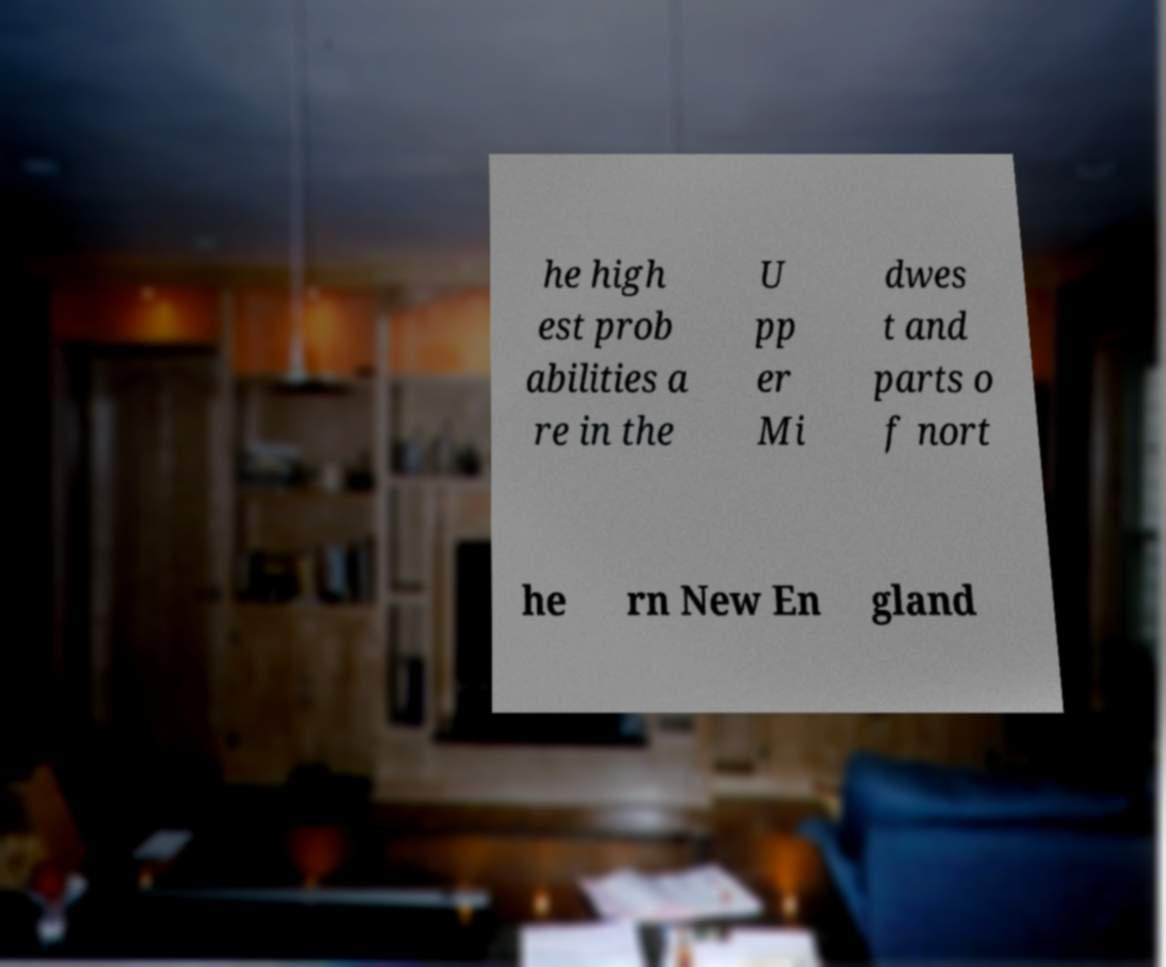Could you extract and type out the text from this image? he high est prob abilities a re in the U pp er Mi dwes t and parts o f nort he rn New En gland 